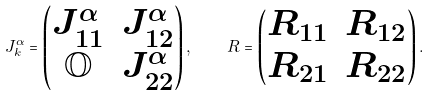Convert formula to latex. <formula><loc_0><loc_0><loc_500><loc_500>J _ { k } ^ { \alpha } = \left ( \begin{matrix} J _ { 1 1 } ^ { \alpha } & J _ { 1 2 } ^ { \alpha } \\ \mathbb { O } & J _ { 2 2 } ^ { \alpha } \end{matrix} \right ) , \quad R = \left ( \begin{matrix} R _ { 1 1 } & R _ { 1 2 } \\ R _ { 2 1 } & R _ { 2 2 } \end{matrix} \right ) .</formula> 